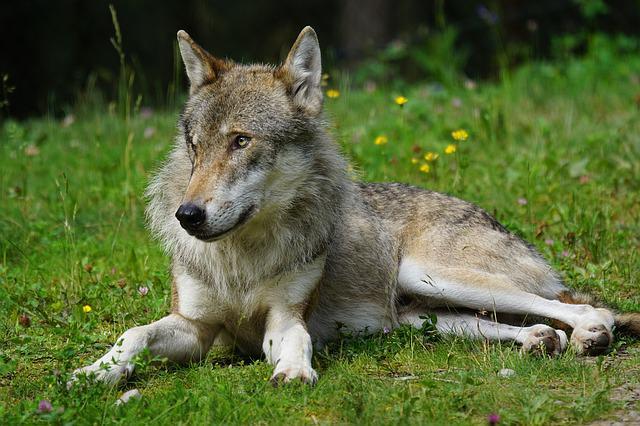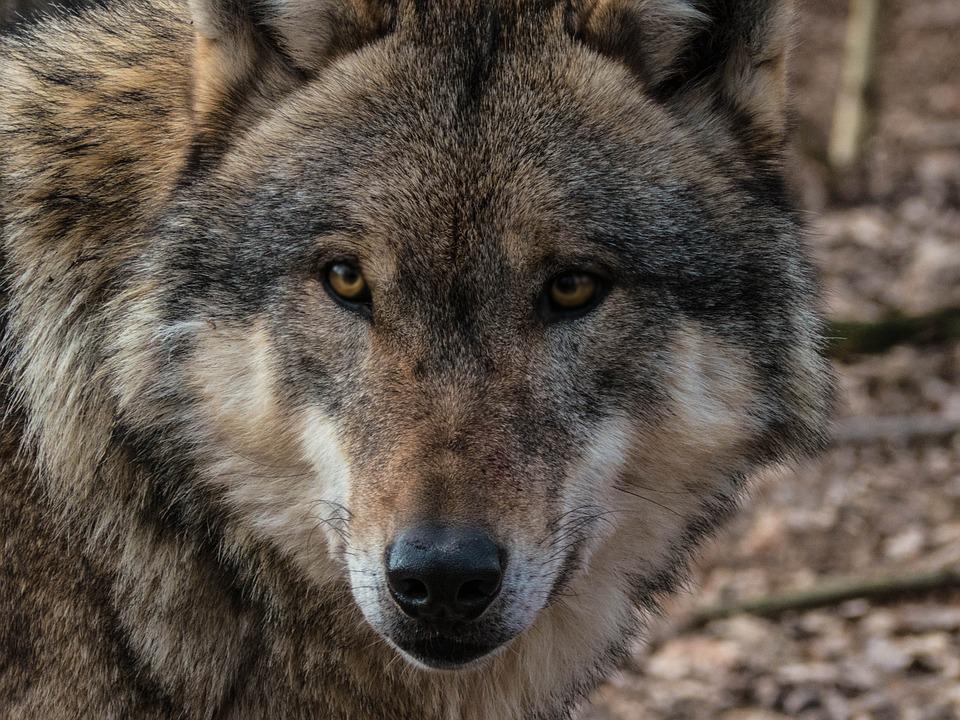The first image is the image on the left, the second image is the image on the right. Assess this claim about the two images: "At least one of the animals is walking in the snow.". Correct or not? Answer yes or no. No. The first image is the image on the left, the second image is the image on the right. For the images displayed, is the sentence "At least one image shows a wolf in a snowy scene." factually correct? Answer yes or no. No. 